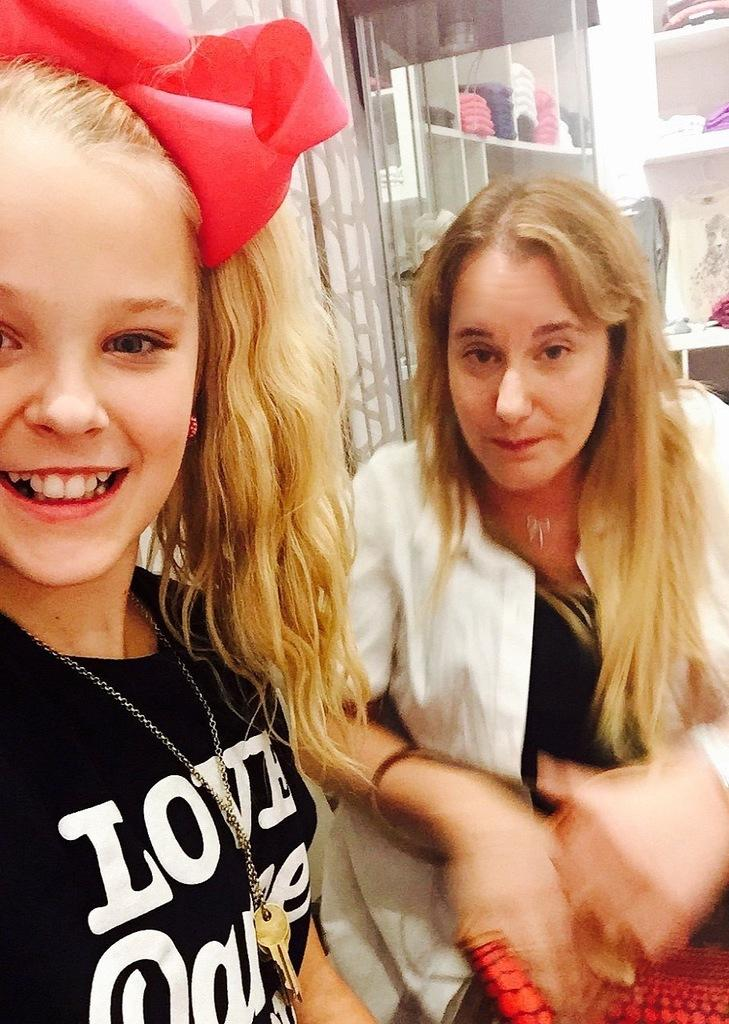How many people are in the image? There are two persons in the image. Can you describe one of the persons? One of the persons is a woman who is smiling. What can be seen in the background of the image? There is a glass object and clothes on a shelf in the background of the image. What type of riddle is being solved by the woman in the image? There is no riddle being solved in the image; the woman is simply smiling. Can you tell me how many vans are parked outside the room in the image? There is no information about vans or any outdoor setting in the image. 